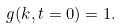Convert formula to latex. <formula><loc_0><loc_0><loc_500><loc_500>g ( k , t = 0 ) = 1 .</formula> 